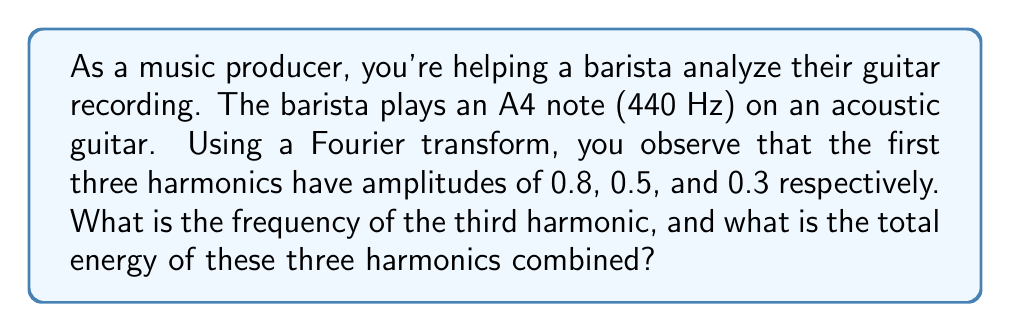Show me your answer to this math problem. Let's approach this step-by-step:

1) The fundamental frequency (first harmonic) of A4 is 440 Hz.

2) Harmonics are integer multiples of the fundamental frequency:
   - 1st harmonic (fundamental): $440 \text{ Hz}$
   - 2nd harmonic: $2 \times 440 = 880 \text{ Hz}$
   - 3rd harmonic: $3 \times 440 = 1320 \text{ Hz}$

3) The frequency of the third harmonic is 1320 Hz.

4) To calculate the total energy, we need to use the formula:
   $E = \sum_{n=1}^{3} A_n^2$
   where $A_n$ is the amplitude of each harmonic.

5) Substituting the given amplitudes:
   $E = 0.8^2 + 0.5^2 + 0.3^2$

6) Calculating:
   $E = 0.64 + 0.25 + 0.09 = 0.98$

Therefore, the frequency of the third harmonic is 1320 Hz, and the total energy of the first three harmonics is 0.98.
Answer: 1320 Hz; 0.98 